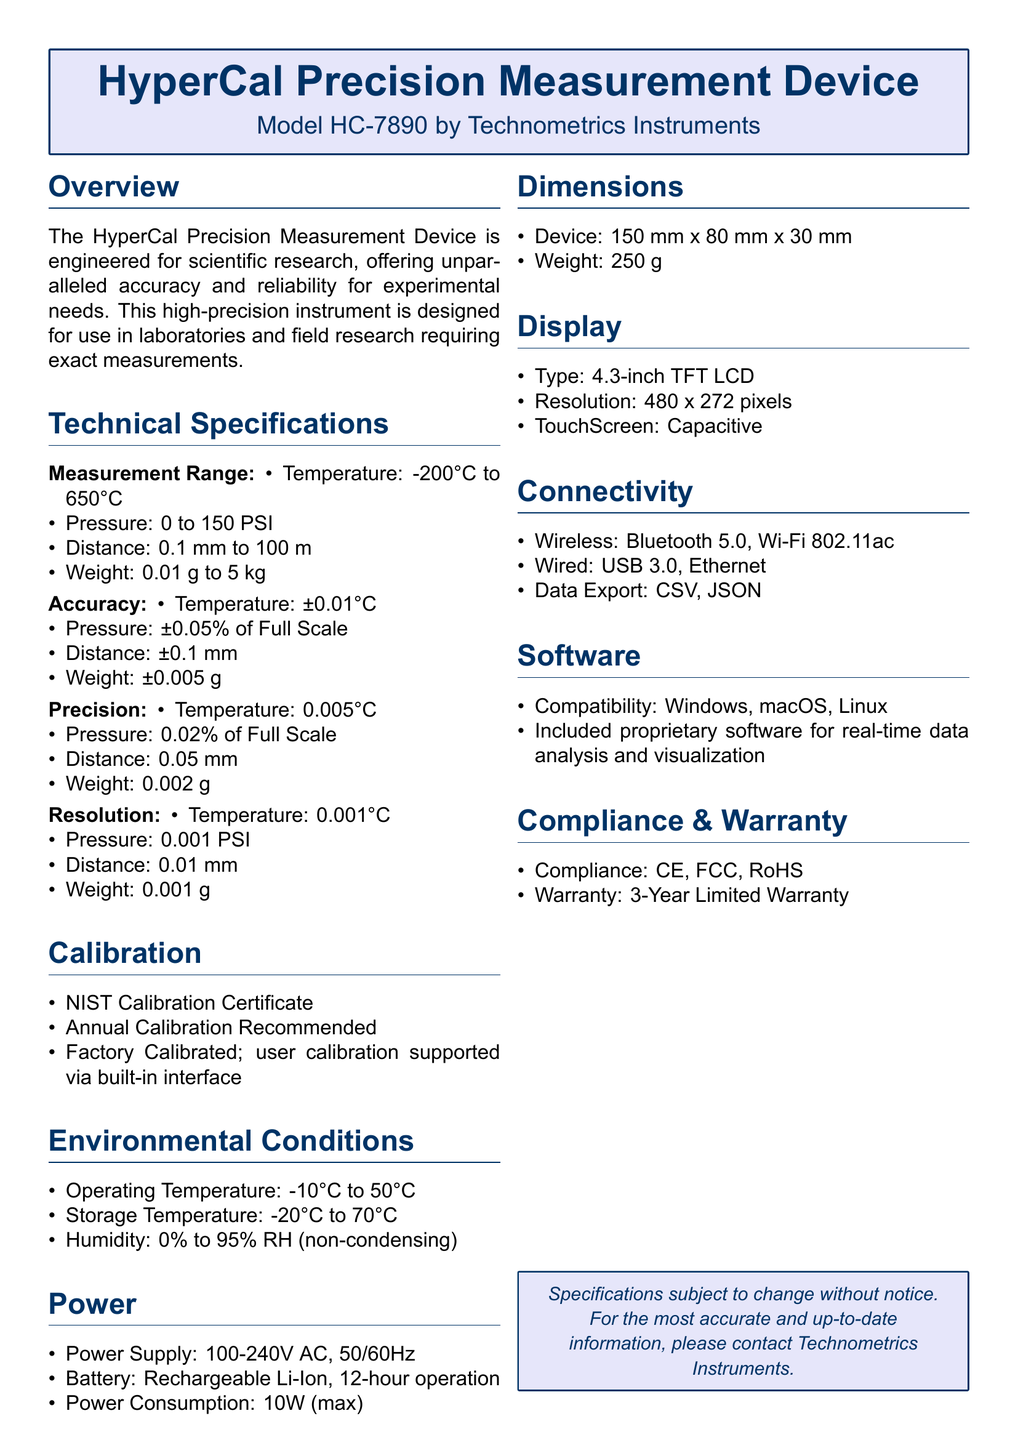What is the measurement range for temperature? The measurement range for temperature is specified in the technical specifications section, indicating the limits of the device's capability.
Answer: -200°C to 650°C What is the weight accuracy? The accuracy of weight is discussed in the accuracy specification, showing how close the measurement will be to the actual weight.
Answer: ±0.005 g What is the precision for distance measurement? The precision for distance measurement is listed in the precision section, which highlights the minimal difference the device can reliably detect.
Answer: 0.05 mm What is the power consumption? The power consumption detail is found in the power section, indicating the maximum energy the device uses during operation.
Answer: 10W (max) What type of display does the device use? The display type is specified in the display section, defining the kind of screen used for output visualization.
Answer: 4.3-inch TFT LCD What is the warranty period? The warranty period detail is found in the compliance section, stating the duration for which the device is covered against defects.
Answer: 3-Year Limited Warranty What is the operating temperature range? The operating temperature range is provided in the environmental conditions section, specifying the temperatures within which the device functions properly.
Answer: -10°C to 50°C What calibration certificate is included? The calibration certificate is mentioned in the calibration section, indicating the standard of validation complied with by the device.
Answer: NIST Calibration Certificate How many pixels is the display resolution? The display resolution detail can be found in the display section, illustrating the clarity of the output visualized on the screen.
Answer: 480 x 272 pixels 